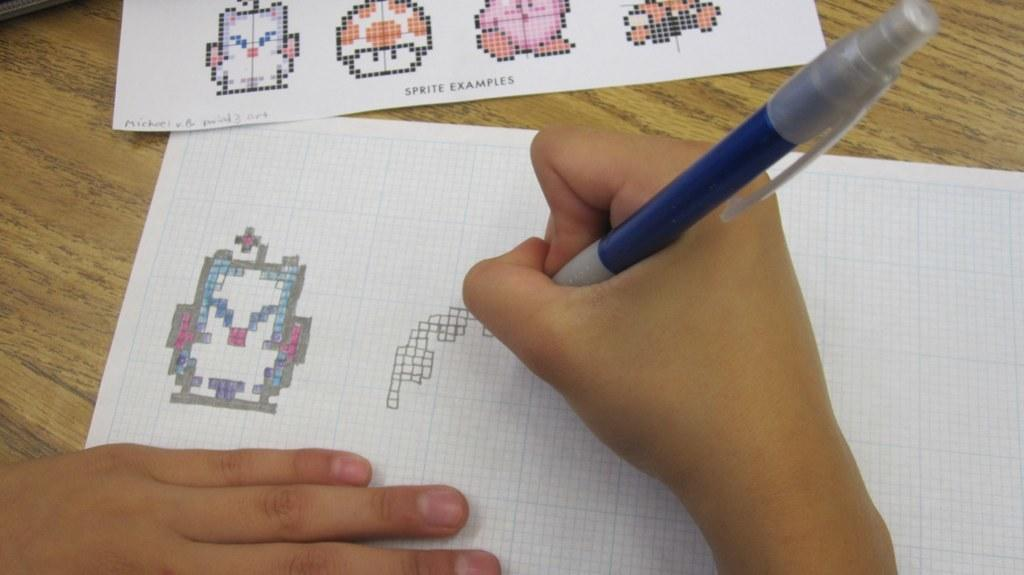What part of a person can be seen in the image? There is a person's hand in the image. What is the person holding in their hand? The person is holding a blue pen. What objects are at the top of the image? There are two papers at the top of the image. Where are the papers placed? The papers are kept on a table. What type of pin can be seen in the person's throat in the image? There is no pin or reference to a person's throat in the image; it only shows a person's hand holding a blue pen and two papers on a table. 